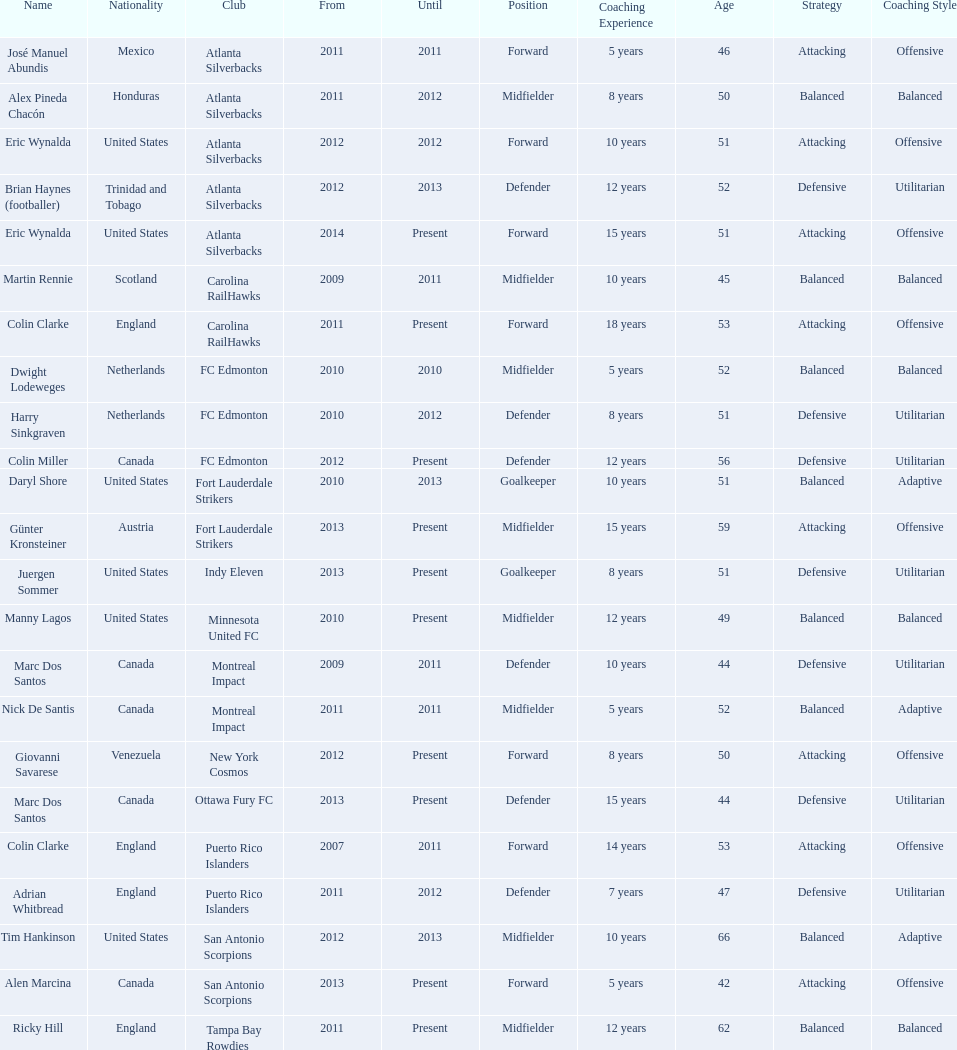Could you parse the entire table as a dict? {'header': ['Name', 'Nationality', 'Club', 'From', 'Until', 'Position', 'Coaching Experience', 'Age', 'Strategy', 'Coaching Style'], 'rows': [['José Manuel Abundis', 'Mexico', 'Atlanta Silverbacks', '2011', '2011', 'Forward', '5 years', '46', 'Attacking', 'Offensive'], ['Alex Pineda Chacón', 'Honduras', 'Atlanta Silverbacks', '2011', '2012', 'Midfielder', '8 years', '50', 'Balanced', 'Balanced'], ['Eric Wynalda', 'United States', 'Atlanta Silverbacks', '2012', '2012', 'Forward', '10 years', '51', 'Attacking', 'Offensive '], ['Brian Haynes (footballer)', 'Trinidad and Tobago', 'Atlanta Silverbacks', '2012', '2013', 'Defender', '12 years', '52', 'Defensive', 'Utilitarian'], ['Eric Wynalda', 'United States', 'Atlanta Silverbacks', '2014', 'Present', 'Forward', '15 years', '51', 'Attacking', 'Offensive'], ['Martin Rennie', 'Scotland', 'Carolina RailHawks', '2009', '2011', 'Midfielder', '10 years', '45', 'Balanced', 'Balanced'], ['Colin Clarke', 'England', 'Carolina RailHawks', '2011', 'Present', 'Forward', '18 years', '53', 'Attacking', 'Offensive'], ['Dwight Lodeweges', 'Netherlands', 'FC Edmonton', '2010', '2010', 'Midfielder', '5 years', '52', 'Balanced', 'Balanced'], ['Harry Sinkgraven', 'Netherlands', 'FC Edmonton', '2010', '2012', 'Defender', '8 years', '51', 'Defensive', 'Utilitarian'], ['Colin Miller', 'Canada', 'FC Edmonton', '2012', 'Present', 'Defender', '12 years', '56', 'Defensive', 'Utilitarian'], ['Daryl Shore', 'United States', 'Fort Lauderdale Strikers', '2010', '2013', 'Goalkeeper', '10 years', '51', 'Balanced', 'Adaptive'], ['Günter Kronsteiner', 'Austria', 'Fort Lauderdale Strikers', '2013', 'Present', 'Midfielder', '15 years', '59', 'Attacking', 'Offensive'], ['Juergen Sommer', 'United States', 'Indy Eleven', '2013', 'Present', 'Goalkeeper', '8 years', '51', 'Defensive', 'Utilitarian'], ['Manny Lagos', 'United States', 'Minnesota United FC', '2010', 'Present', 'Midfielder', '12 years', '49', 'Balanced', 'Balanced'], ['Marc Dos Santos', 'Canada', 'Montreal Impact', '2009', '2011', 'Defender', '10 years', '44', 'Defensive', 'Utilitarian'], ['Nick De Santis', 'Canada', 'Montreal Impact', '2011', '2011', 'Midfielder', '5 years', '52', 'Balanced', 'Adaptive'], ['Giovanni Savarese', 'Venezuela', 'New York Cosmos', '2012', 'Present', 'Forward', '8 years', '50', 'Attacking', 'Offensive'], ['Marc Dos Santos', 'Canada', 'Ottawa Fury FC', '2013', 'Present', 'Defender', '15 years', '44', 'Defensive', 'Utilitarian'], ['Colin Clarke', 'England', 'Puerto Rico Islanders', '2007', '2011', 'Forward', '14 years', '53', 'Attacking', 'Offensive'], ['Adrian Whitbread', 'England', 'Puerto Rico Islanders', '2011', '2012', 'Defender', '7 years', '47', 'Defensive', 'Utilitarian'], ['Tim Hankinson', 'United States', 'San Antonio Scorpions', '2012', '2013', 'Midfielder', '10 years', '66', 'Balanced', 'Adaptive'], ['Alen Marcina', 'Canada', 'San Antonio Scorpions', '2013', 'Present', 'Forward', '5 years', '42', 'Attacking', 'Offensive'], ['Ricky Hill', 'England', 'Tampa Bay Rowdies', '2011', 'Present', 'Midfielder', '12 years', '62', 'Balanced', 'Balanced']]} What were all the coaches who were coaching in 2010? Martin Rennie, Dwight Lodeweges, Harry Sinkgraven, Daryl Shore, Manny Lagos, Marc Dos Santos, Colin Clarke. Which of the 2010 coaches were not born in north america? Martin Rennie, Dwight Lodeweges, Harry Sinkgraven, Colin Clarke. Which coaches that were coaching in 2010 and were not from north america did not coach for fc edmonton? Martin Rennie, Colin Clarke. What coach did not coach for fc edmonton in 2010 and was not north american nationality had the shortened career as a coach? Martin Rennie. 